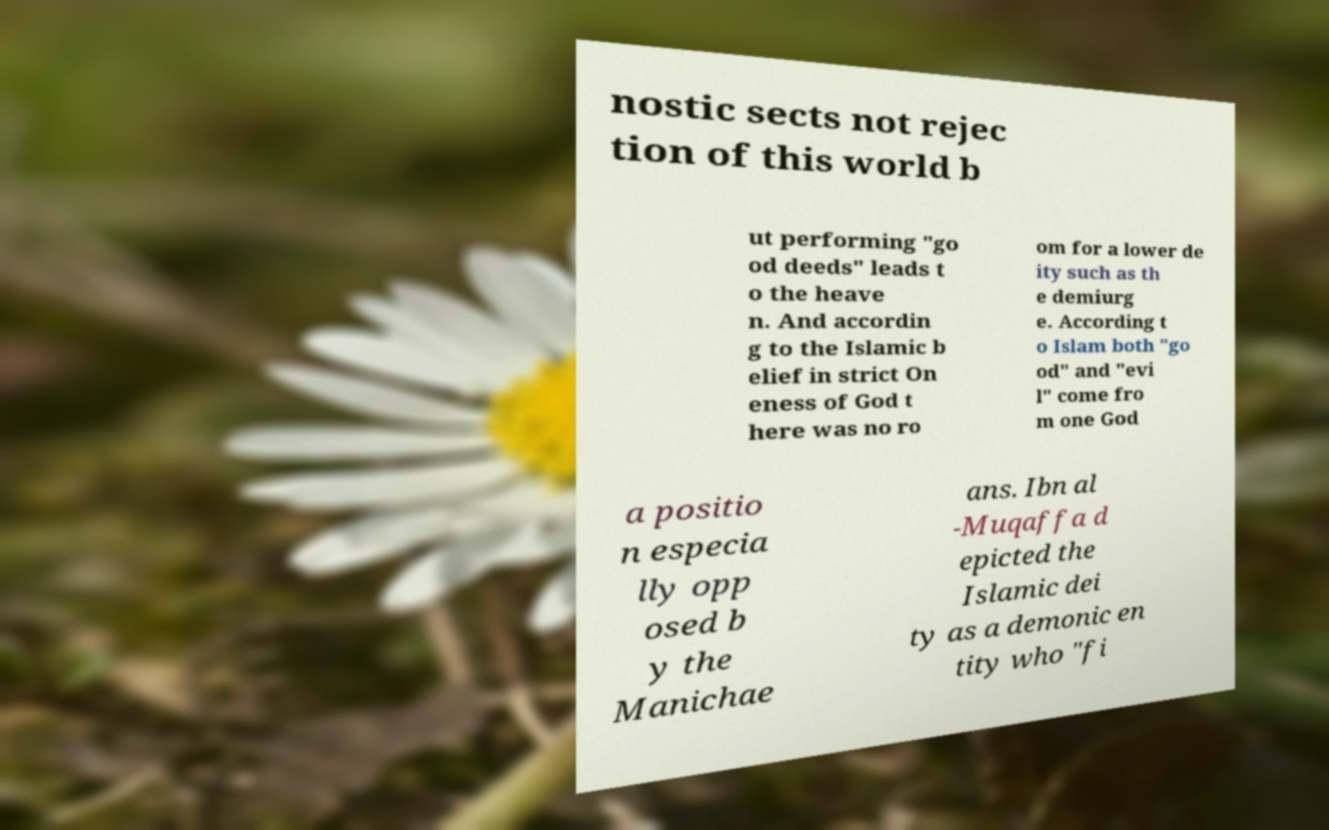I need the written content from this picture converted into text. Can you do that? nostic sects not rejec tion of this world b ut performing "go od deeds" leads t o the heave n. And accordin g to the Islamic b elief in strict On eness of God t here was no ro om for a lower de ity such as th e demiurg e. According t o Islam both "go od" and "evi l" come fro m one God a positio n especia lly opp osed b y the Manichae ans. Ibn al -Muqaffa d epicted the Islamic dei ty as a demonic en tity who "fi 